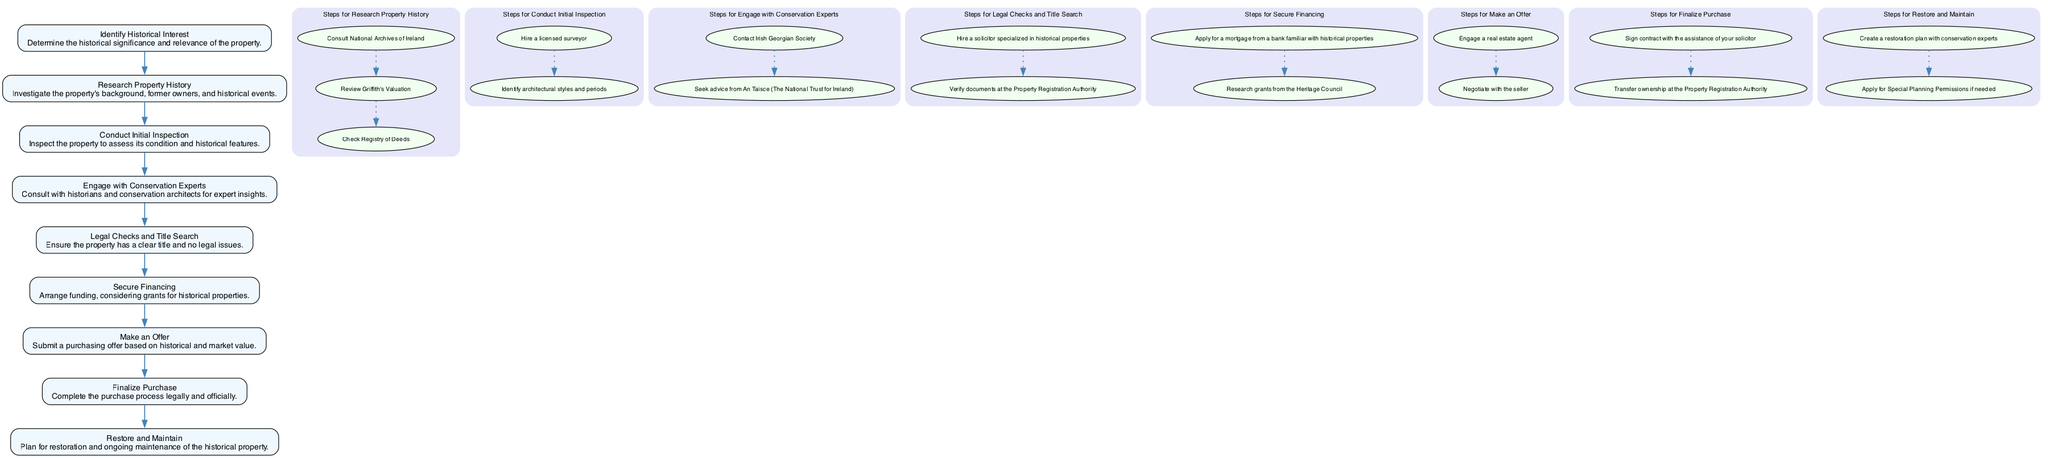What is the first step in the process? The first step in the diagram is "Identify Historical Interest," which starts the process of purchasing a historical residential property in Ireland.
Answer: Identify Historical Interest How many steps are involved in the "Legal Checks and Title Search"? The "Legal Checks and Title Search" has 2 steps listed under it: hiring a solicitor and verifying documents at the Property Registration Authority.
Answer: 2 steps Which node has the description regarding conservation experts? The node that has the description regarding conservation experts is "Engage with Conservation Experts." It outlines consulting with historians and conservation architects.
Answer: Engage with Conservation Experts What is the last step in the purchasing process? The last step in the purchasing process is "Restore and Maintain," which emphasizes planning for the restoration and ongoing maintenance of the historical property.
Answer: Restore and Maintain How do you transition from "Make an Offer" to "Finalize Purchase"? The transition from "Make an Offer" to "Finalize Purchase" is direct; "Finalize Purchase" follows immediately after "Make an Offer" in the flow of the diagram.
Answer: Direct transition How many nodes represent the research phase of property history? There is one node representing the research phase of property history, which is "Research Property History." It includes multiple steps associated with this phase.
Answer: 1 node What are the two major entities consulted in the "Engage with Conservation Experts"? The two major entities consulted in this step are the Irish Georgian Society and An Taisce (The National Trust for Ireland).
Answer: Irish Georgian Society and An Taisce Which step comes immediately after "Secure Financing"? The step that comes immediately after "Secure Financing" is "Make an Offer," indicating a sequential progression in the purchasing process.
Answer: Make an Offer What is the primary focus of the "Restore and Maintain" step? The primary focus of the "Restore and Maintain" step is to plan for restoration and ongoing maintenance of the historical property.
Answer: Restoration and ongoing maintenance 